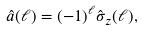<formula> <loc_0><loc_0><loc_500><loc_500>\hat { a } ( \ell ) = ( - 1 ) ^ { \ell } \hat { \sigma } _ { z } ( \ell ) ,</formula> 